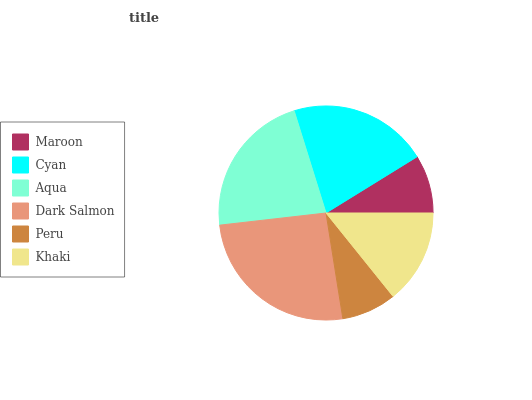Is Peru the minimum?
Answer yes or no. Yes. Is Dark Salmon the maximum?
Answer yes or no. Yes. Is Cyan the minimum?
Answer yes or no. No. Is Cyan the maximum?
Answer yes or no. No. Is Cyan greater than Maroon?
Answer yes or no. Yes. Is Maroon less than Cyan?
Answer yes or no. Yes. Is Maroon greater than Cyan?
Answer yes or no. No. Is Cyan less than Maroon?
Answer yes or no. No. Is Cyan the high median?
Answer yes or no. Yes. Is Khaki the low median?
Answer yes or no. Yes. Is Khaki the high median?
Answer yes or no. No. Is Dark Salmon the low median?
Answer yes or no. No. 